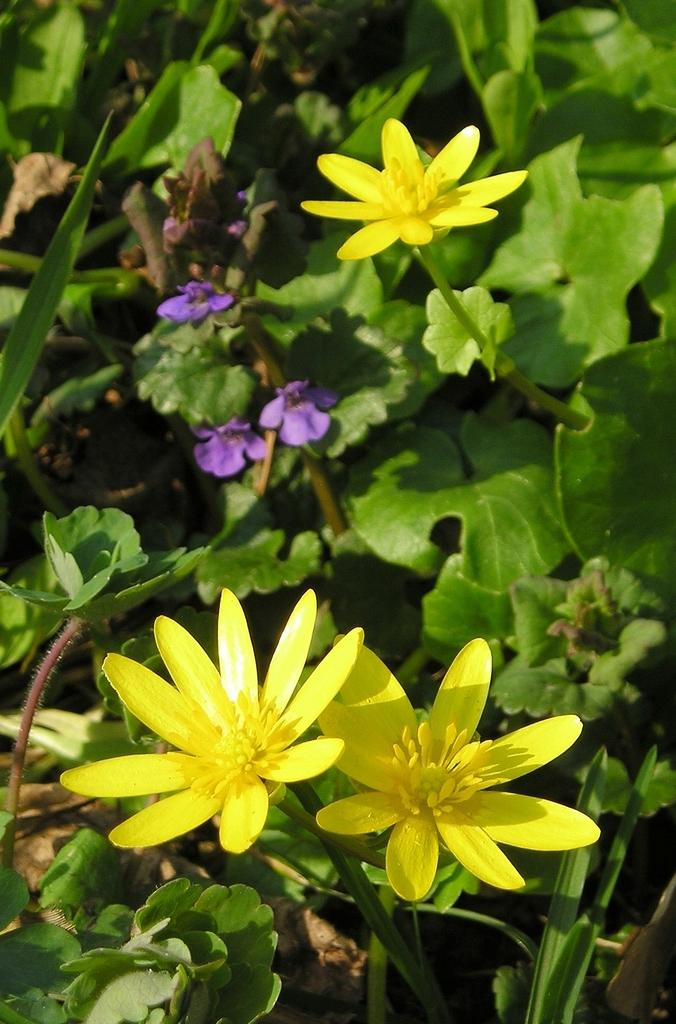What color are the flowers in the front of the image? The flowers in the front of the image are yellow. What color are the flowers that are behind the yellow flowers? The flowers that are behind the yellow flowers are purple. Where are the purple flowers located in relation to the plants? The purple flowers are on plants. What type of feather can be seen on the actor in the image? There is no actor or feather present in the image; it features yellow and purple flowers on plants. 